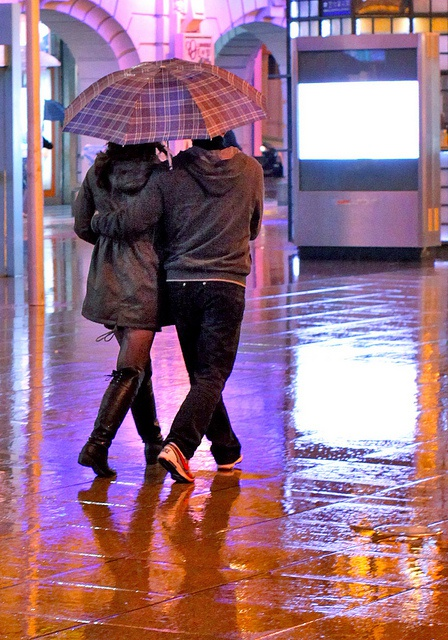Describe the objects in this image and their specific colors. I can see people in pink, black, maroon, gray, and purple tones, people in pink, black, maroon, gray, and purple tones, tv in pink, white, purple, blue, and darkblue tones, and umbrella in pink, brown, violet, and purple tones in this image. 